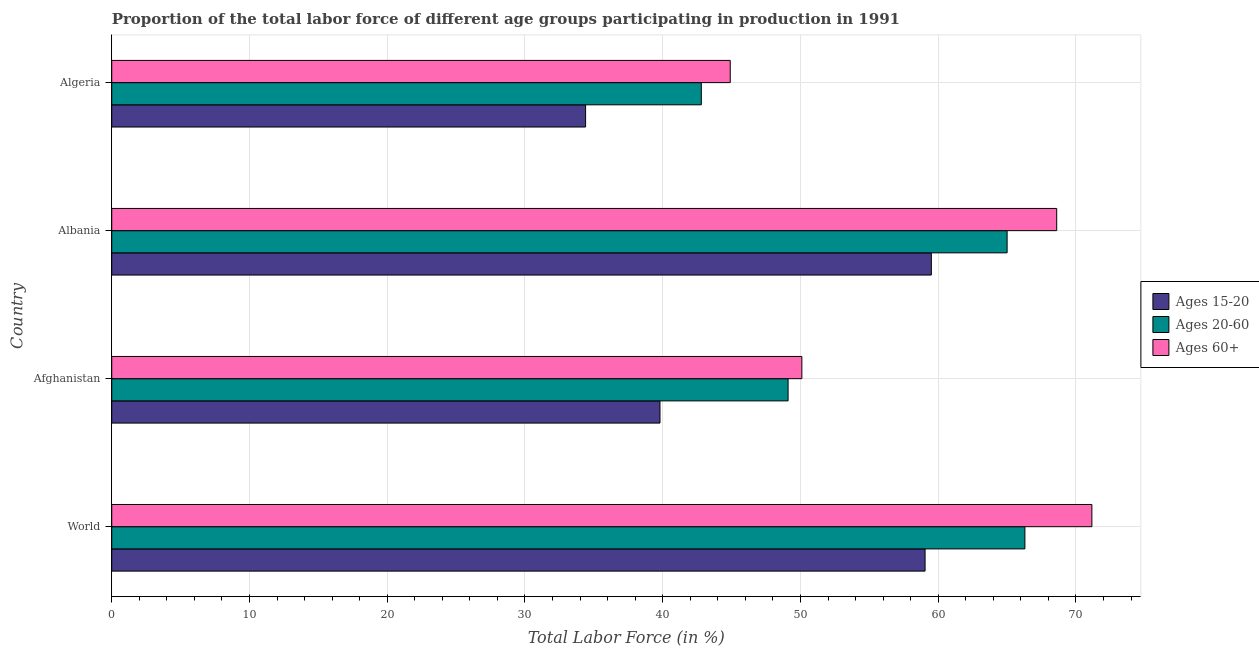How many bars are there on the 1st tick from the top?
Provide a short and direct response. 3. In how many cases, is the number of bars for a given country not equal to the number of legend labels?
Make the answer very short. 0. What is the percentage of labor force within the age group 15-20 in Afghanistan?
Offer a terse response. 39.8. Across all countries, what is the maximum percentage of labor force within the age group 20-60?
Make the answer very short. 66.29. Across all countries, what is the minimum percentage of labor force above age 60?
Keep it short and to the point. 44.9. In which country was the percentage of labor force above age 60 maximum?
Your response must be concise. World. In which country was the percentage of labor force within the age group 15-20 minimum?
Your answer should be very brief. Algeria. What is the total percentage of labor force above age 60 in the graph?
Offer a terse response. 234.75. What is the difference between the percentage of labor force within the age group 15-20 in Albania and that in Algeria?
Make the answer very short. 25.1. What is the difference between the percentage of labor force above age 60 in Albania and the percentage of labor force within the age group 20-60 in Algeria?
Give a very brief answer. 25.8. What is the average percentage of labor force above age 60 per country?
Make the answer very short. 58.69. What is the difference between the percentage of labor force within the age group 15-20 and percentage of labor force above age 60 in Algeria?
Offer a very short reply. -10.5. In how many countries, is the percentage of labor force within the age group 20-60 greater than 20 %?
Provide a short and direct response. 4. What is the ratio of the percentage of labor force within the age group 20-60 in Afghanistan to that in Algeria?
Provide a short and direct response. 1.15. Is the percentage of labor force within the age group 15-20 in Albania less than that in World?
Your answer should be very brief. No. What is the difference between the highest and the second highest percentage of labor force above age 60?
Offer a terse response. 2.55. What is the difference between the highest and the lowest percentage of labor force within the age group 20-60?
Make the answer very short. 23.49. What does the 2nd bar from the top in World represents?
Your answer should be very brief. Ages 20-60. What does the 1st bar from the bottom in Algeria represents?
Your response must be concise. Ages 15-20. Are all the bars in the graph horizontal?
Offer a very short reply. Yes. How many legend labels are there?
Your answer should be very brief. 3. How are the legend labels stacked?
Give a very brief answer. Vertical. What is the title of the graph?
Provide a succinct answer. Proportion of the total labor force of different age groups participating in production in 1991. What is the label or title of the X-axis?
Ensure brevity in your answer.  Total Labor Force (in %). What is the label or title of the Y-axis?
Give a very brief answer. Country. What is the Total Labor Force (in %) of Ages 15-20 in World?
Your response must be concise. 59.04. What is the Total Labor Force (in %) in Ages 20-60 in World?
Your answer should be compact. 66.29. What is the Total Labor Force (in %) in Ages 60+ in World?
Your answer should be compact. 71.15. What is the Total Labor Force (in %) of Ages 15-20 in Afghanistan?
Your answer should be very brief. 39.8. What is the Total Labor Force (in %) in Ages 20-60 in Afghanistan?
Offer a terse response. 49.1. What is the Total Labor Force (in %) in Ages 60+ in Afghanistan?
Your answer should be compact. 50.1. What is the Total Labor Force (in %) of Ages 15-20 in Albania?
Your response must be concise. 59.5. What is the Total Labor Force (in %) in Ages 20-60 in Albania?
Your answer should be compact. 65. What is the Total Labor Force (in %) of Ages 60+ in Albania?
Ensure brevity in your answer.  68.6. What is the Total Labor Force (in %) in Ages 15-20 in Algeria?
Make the answer very short. 34.4. What is the Total Labor Force (in %) in Ages 20-60 in Algeria?
Your answer should be very brief. 42.8. What is the Total Labor Force (in %) in Ages 60+ in Algeria?
Your response must be concise. 44.9. Across all countries, what is the maximum Total Labor Force (in %) of Ages 15-20?
Offer a very short reply. 59.5. Across all countries, what is the maximum Total Labor Force (in %) of Ages 20-60?
Your response must be concise. 66.29. Across all countries, what is the maximum Total Labor Force (in %) of Ages 60+?
Offer a very short reply. 71.15. Across all countries, what is the minimum Total Labor Force (in %) of Ages 15-20?
Ensure brevity in your answer.  34.4. Across all countries, what is the minimum Total Labor Force (in %) of Ages 20-60?
Offer a very short reply. 42.8. Across all countries, what is the minimum Total Labor Force (in %) in Ages 60+?
Make the answer very short. 44.9. What is the total Total Labor Force (in %) in Ages 15-20 in the graph?
Offer a terse response. 192.74. What is the total Total Labor Force (in %) of Ages 20-60 in the graph?
Offer a terse response. 223.19. What is the total Total Labor Force (in %) of Ages 60+ in the graph?
Give a very brief answer. 234.75. What is the difference between the Total Labor Force (in %) in Ages 15-20 in World and that in Afghanistan?
Ensure brevity in your answer.  19.24. What is the difference between the Total Labor Force (in %) in Ages 20-60 in World and that in Afghanistan?
Ensure brevity in your answer.  17.19. What is the difference between the Total Labor Force (in %) of Ages 60+ in World and that in Afghanistan?
Your answer should be compact. 21.05. What is the difference between the Total Labor Force (in %) of Ages 15-20 in World and that in Albania?
Give a very brief answer. -0.46. What is the difference between the Total Labor Force (in %) in Ages 20-60 in World and that in Albania?
Give a very brief answer. 1.29. What is the difference between the Total Labor Force (in %) of Ages 60+ in World and that in Albania?
Ensure brevity in your answer.  2.55. What is the difference between the Total Labor Force (in %) of Ages 15-20 in World and that in Algeria?
Your response must be concise. 24.64. What is the difference between the Total Labor Force (in %) in Ages 20-60 in World and that in Algeria?
Make the answer very short. 23.49. What is the difference between the Total Labor Force (in %) of Ages 60+ in World and that in Algeria?
Provide a short and direct response. 26.25. What is the difference between the Total Labor Force (in %) of Ages 15-20 in Afghanistan and that in Albania?
Provide a short and direct response. -19.7. What is the difference between the Total Labor Force (in %) of Ages 20-60 in Afghanistan and that in Albania?
Keep it short and to the point. -15.9. What is the difference between the Total Labor Force (in %) of Ages 60+ in Afghanistan and that in Albania?
Ensure brevity in your answer.  -18.5. What is the difference between the Total Labor Force (in %) of Ages 20-60 in Afghanistan and that in Algeria?
Make the answer very short. 6.3. What is the difference between the Total Labor Force (in %) of Ages 15-20 in Albania and that in Algeria?
Your answer should be very brief. 25.1. What is the difference between the Total Labor Force (in %) of Ages 60+ in Albania and that in Algeria?
Ensure brevity in your answer.  23.7. What is the difference between the Total Labor Force (in %) in Ages 15-20 in World and the Total Labor Force (in %) in Ages 20-60 in Afghanistan?
Offer a very short reply. 9.94. What is the difference between the Total Labor Force (in %) of Ages 15-20 in World and the Total Labor Force (in %) of Ages 60+ in Afghanistan?
Ensure brevity in your answer.  8.94. What is the difference between the Total Labor Force (in %) in Ages 20-60 in World and the Total Labor Force (in %) in Ages 60+ in Afghanistan?
Provide a succinct answer. 16.19. What is the difference between the Total Labor Force (in %) of Ages 15-20 in World and the Total Labor Force (in %) of Ages 20-60 in Albania?
Give a very brief answer. -5.96. What is the difference between the Total Labor Force (in %) of Ages 15-20 in World and the Total Labor Force (in %) of Ages 60+ in Albania?
Your answer should be compact. -9.56. What is the difference between the Total Labor Force (in %) in Ages 20-60 in World and the Total Labor Force (in %) in Ages 60+ in Albania?
Offer a very short reply. -2.31. What is the difference between the Total Labor Force (in %) of Ages 15-20 in World and the Total Labor Force (in %) of Ages 20-60 in Algeria?
Your response must be concise. 16.24. What is the difference between the Total Labor Force (in %) in Ages 15-20 in World and the Total Labor Force (in %) in Ages 60+ in Algeria?
Offer a terse response. 14.14. What is the difference between the Total Labor Force (in %) in Ages 20-60 in World and the Total Labor Force (in %) in Ages 60+ in Algeria?
Provide a succinct answer. 21.39. What is the difference between the Total Labor Force (in %) in Ages 15-20 in Afghanistan and the Total Labor Force (in %) in Ages 20-60 in Albania?
Ensure brevity in your answer.  -25.2. What is the difference between the Total Labor Force (in %) in Ages 15-20 in Afghanistan and the Total Labor Force (in %) in Ages 60+ in Albania?
Ensure brevity in your answer.  -28.8. What is the difference between the Total Labor Force (in %) of Ages 20-60 in Afghanistan and the Total Labor Force (in %) of Ages 60+ in Albania?
Make the answer very short. -19.5. What is the difference between the Total Labor Force (in %) in Ages 20-60 in Afghanistan and the Total Labor Force (in %) in Ages 60+ in Algeria?
Ensure brevity in your answer.  4.2. What is the difference between the Total Labor Force (in %) of Ages 15-20 in Albania and the Total Labor Force (in %) of Ages 20-60 in Algeria?
Give a very brief answer. 16.7. What is the difference between the Total Labor Force (in %) in Ages 15-20 in Albania and the Total Labor Force (in %) in Ages 60+ in Algeria?
Your response must be concise. 14.6. What is the difference between the Total Labor Force (in %) in Ages 20-60 in Albania and the Total Labor Force (in %) in Ages 60+ in Algeria?
Ensure brevity in your answer.  20.1. What is the average Total Labor Force (in %) of Ages 15-20 per country?
Make the answer very short. 48.19. What is the average Total Labor Force (in %) in Ages 20-60 per country?
Your answer should be very brief. 55.8. What is the average Total Labor Force (in %) of Ages 60+ per country?
Provide a succinct answer. 58.69. What is the difference between the Total Labor Force (in %) in Ages 15-20 and Total Labor Force (in %) in Ages 20-60 in World?
Keep it short and to the point. -7.25. What is the difference between the Total Labor Force (in %) in Ages 15-20 and Total Labor Force (in %) in Ages 60+ in World?
Provide a short and direct response. -12.11. What is the difference between the Total Labor Force (in %) in Ages 20-60 and Total Labor Force (in %) in Ages 60+ in World?
Provide a succinct answer. -4.86. What is the difference between the Total Labor Force (in %) of Ages 15-20 and Total Labor Force (in %) of Ages 60+ in Afghanistan?
Ensure brevity in your answer.  -10.3. What is the difference between the Total Labor Force (in %) in Ages 15-20 and Total Labor Force (in %) in Ages 20-60 in Albania?
Provide a short and direct response. -5.5. What is the difference between the Total Labor Force (in %) of Ages 15-20 and Total Labor Force (in %) of Ages 60+ in Albania?
Give a very brief answer. -9.1. What is the difference between the Total Labor Force (in %) of Ages 15-20 and Total Labor Force (in %) of Ages 60+ in Algeria?
Keep it short and to the point. -10.5. What is the difference between the Total Labor Force (in %) of Ages 20-60 and Total Labor Force (in %) of Ages 60+ in Algeria?
Keep it short and to the point. -2.1. What is the ratio of the Total Labor Force (in %) of Ages 15-20 in World to that in Afghanistan?
Your response must be concise. 1.48. What is the ratio of the Total Labor Force (in %) in Ages 20-60 in World to that in Afghanistan?
Keep it short and to the point. 1.35. What is the ratio of the Total Labor Force (in %) of Ages 60+ in World to that in Afghanistan?
Your answer should be compact. 1.42. What is the ratio of the Total Labor Force (in %) in Ages 20-60 in World to that in Albania?
Give a very brief answer. 1.02. What is the ratio of the Total Labor Force (in %) of Ages 60+ in World to that in Albania?
Offer a very short reply. 1.04. What is the ratio of the Total Labor Force (in %) in Ages 15-20 in World to that in Algeria?
Make the answer very short. 1.72. What is the ratio of the Total Labor Force (in %) of Ages 20-60 in World to that in Algeria?
Your answer should be compact. 1.55. What is the ratio of the Total Labor Force (in %) of Ages 60+ in World to that in Algeria?
Your answer should be compact. 1.58. What is the ratio of the Total Labor Force (in %) of Ages 15-20 in Afghanistan to that in Albania?
Your response must be concise. 0.67. What is the ratio of the Total Labor Force (in %) in Ages 20-60 in Afghanistan to that in Albania?
Ensure brevity in your answer.  0.76. What is the ratio of the Total Labor Force (in %) of Ages 60+ in Afghanistan to that in Albania?
Offer a terse response. 0.73. What is the ratio of the Total Labor Force (in %) in Ages 15-20 in Afghanistan to that in Algeria?
Provide a short and direct response. 1.16. What is the ratio of the Total Labor Force (in %) of Ages 20-60 in Afghanistan to that in Algeria?
Keep it short and to the point. 1.15. What is the ratio of the Total Labor Force (in %) in Ages 60+ in Afghanistan to that in Algeria?
Offer a terse response. 1.12. What is the ratio of the Total Labor Force (in %) of Ages 15-20 in Albania to that in Algeria?
Ensure brevity in your answer.  1.73. What is the ratio of the Total Labor Force (in %) of Ages 20-60 in Albania to that in Algeria?
Make the answer very short. 1.52. What is the ratio of the Total Labor Force (in %) in Ages 60+ in Albania to that in Algeria?
Your answer should be very brief. 1.53. What is the difference between the highest and the second highest Total Labor Force (in %) of Ages 15-20?
Your answer should be compact. 0.46. What is the difference between the highest and the second highest Total Labor Force (in %) of Ages 20-60?
Offer a terse response. 1.29. What is the difference between the highest and the second highest Total Labor Force (in %) of Ages 60+?
Your answer should be very brief. 2.55. What is the difference between the highest and the lowest Total Labor Force (in %) in Ages 15-20?
Your answer should be compact. 25.1. What is the difference between the highest and the lowest Total Labor Force (in %) in Ages 20-60?
Your answer should be very brief. 23.49. What is the difference between the highest and the lowest Total Labor Force (in %) in Ages 60+?
Ensure brevity in your answer.  26.25. 